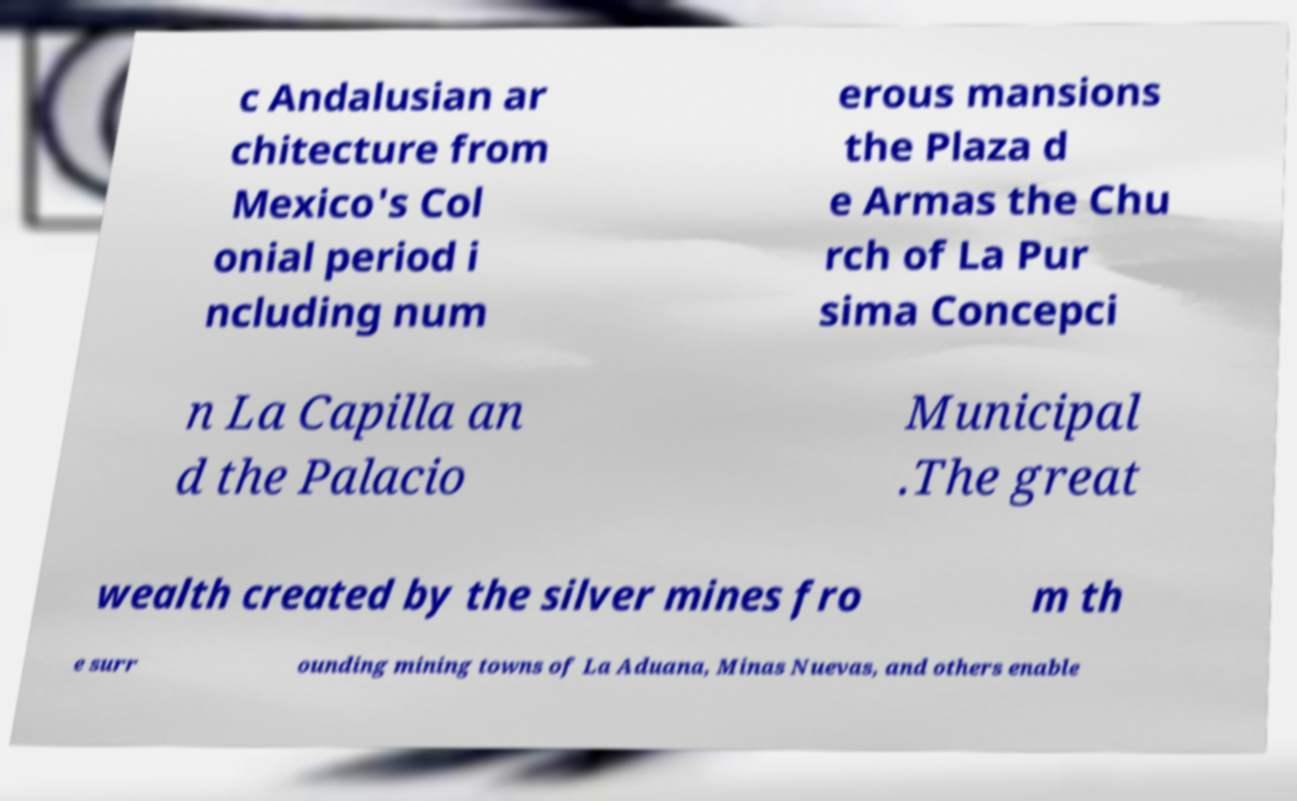There's text embedded in this image that I need extracted. Can you transcribe it verbatim? c Andalusian ar chitecture from Mexico's Col onial period i ncluding num erous mansions the Plaza d e Armas the Chu rch of La Pur sima Concepci n La Capilla an d the Palacio Municipal .The great wealth created by the silver mines fro m th e surr ounding mining towns of La Aduana, Minas Nuevas, and others enable 